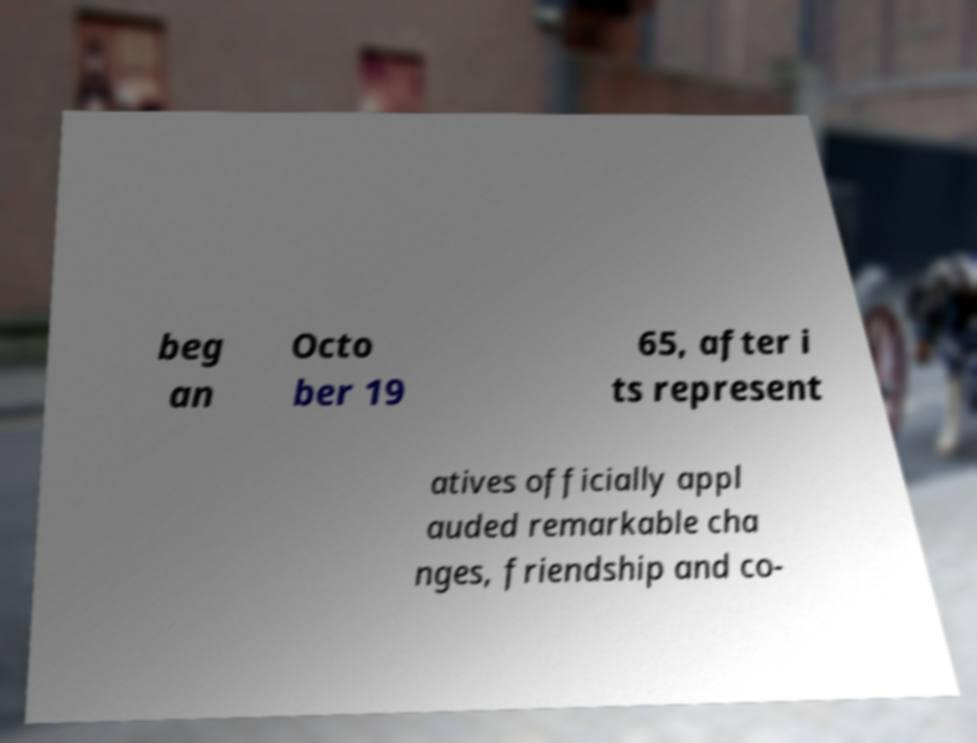Please read and relay the text visible in this image. What does it say? beg an Octo ber 19 65, after i ts represent atives officially appl auded remarkable cha nges, friendship and co- 